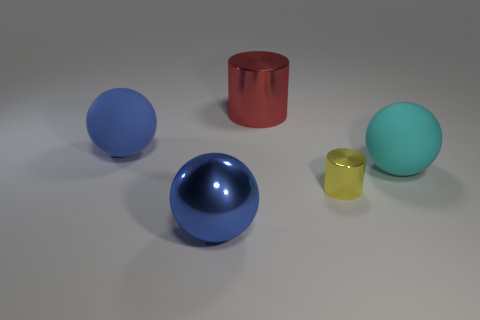Subtract all large metallic spheres. How many spheres are left? 2 Add 1 big matte things. How many objects exist? 6 Subtract all balls. How many objects are left? 2 Add 1 yellow things. How many yellow things are left? 2 Add 4 tiny cylinders. How many tiny cylinders exist? 5 Subtract 0 blue blocks. How many objects are left? 5 Subtract all large blue rubber objects. Subtract all blue metal spheres. How many objects are left? 3 